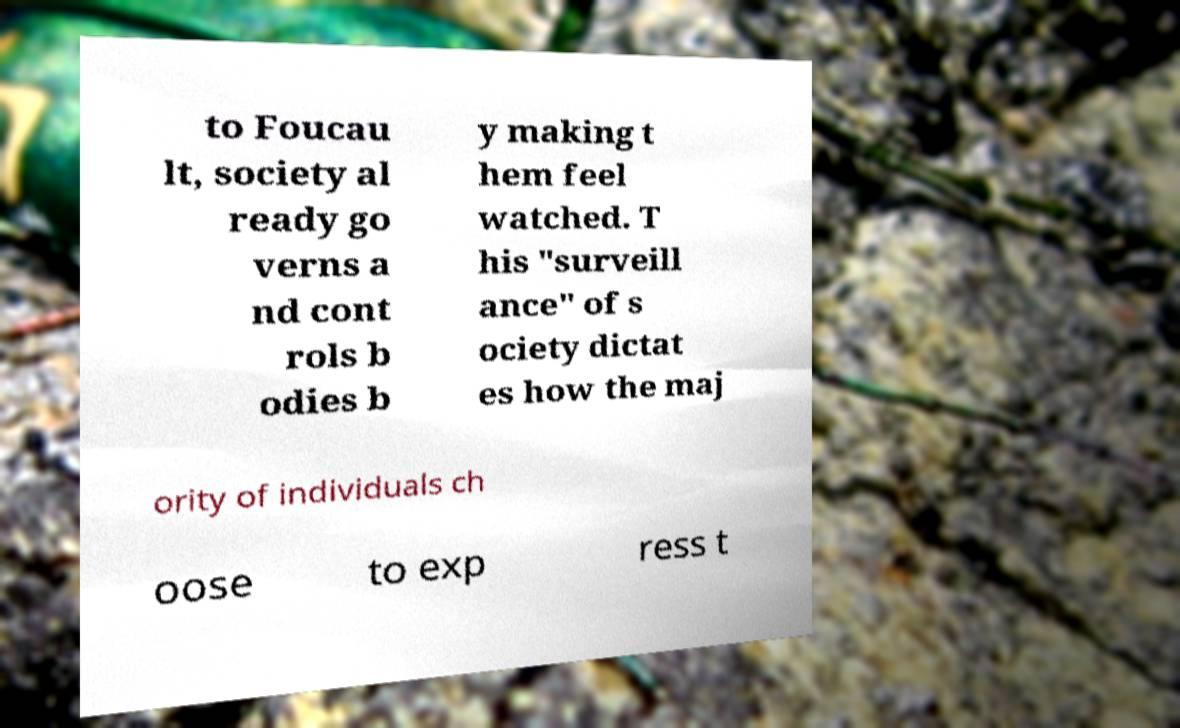I need the written content from this picture converted into text. Can you do that? to Foucau lt, society al ready go verns a nd cont rols b odies b y making t hem feel watched. T his "surveill ance" of s ociety dictat es how the maj ority of individuals ch oose to exp ress t 